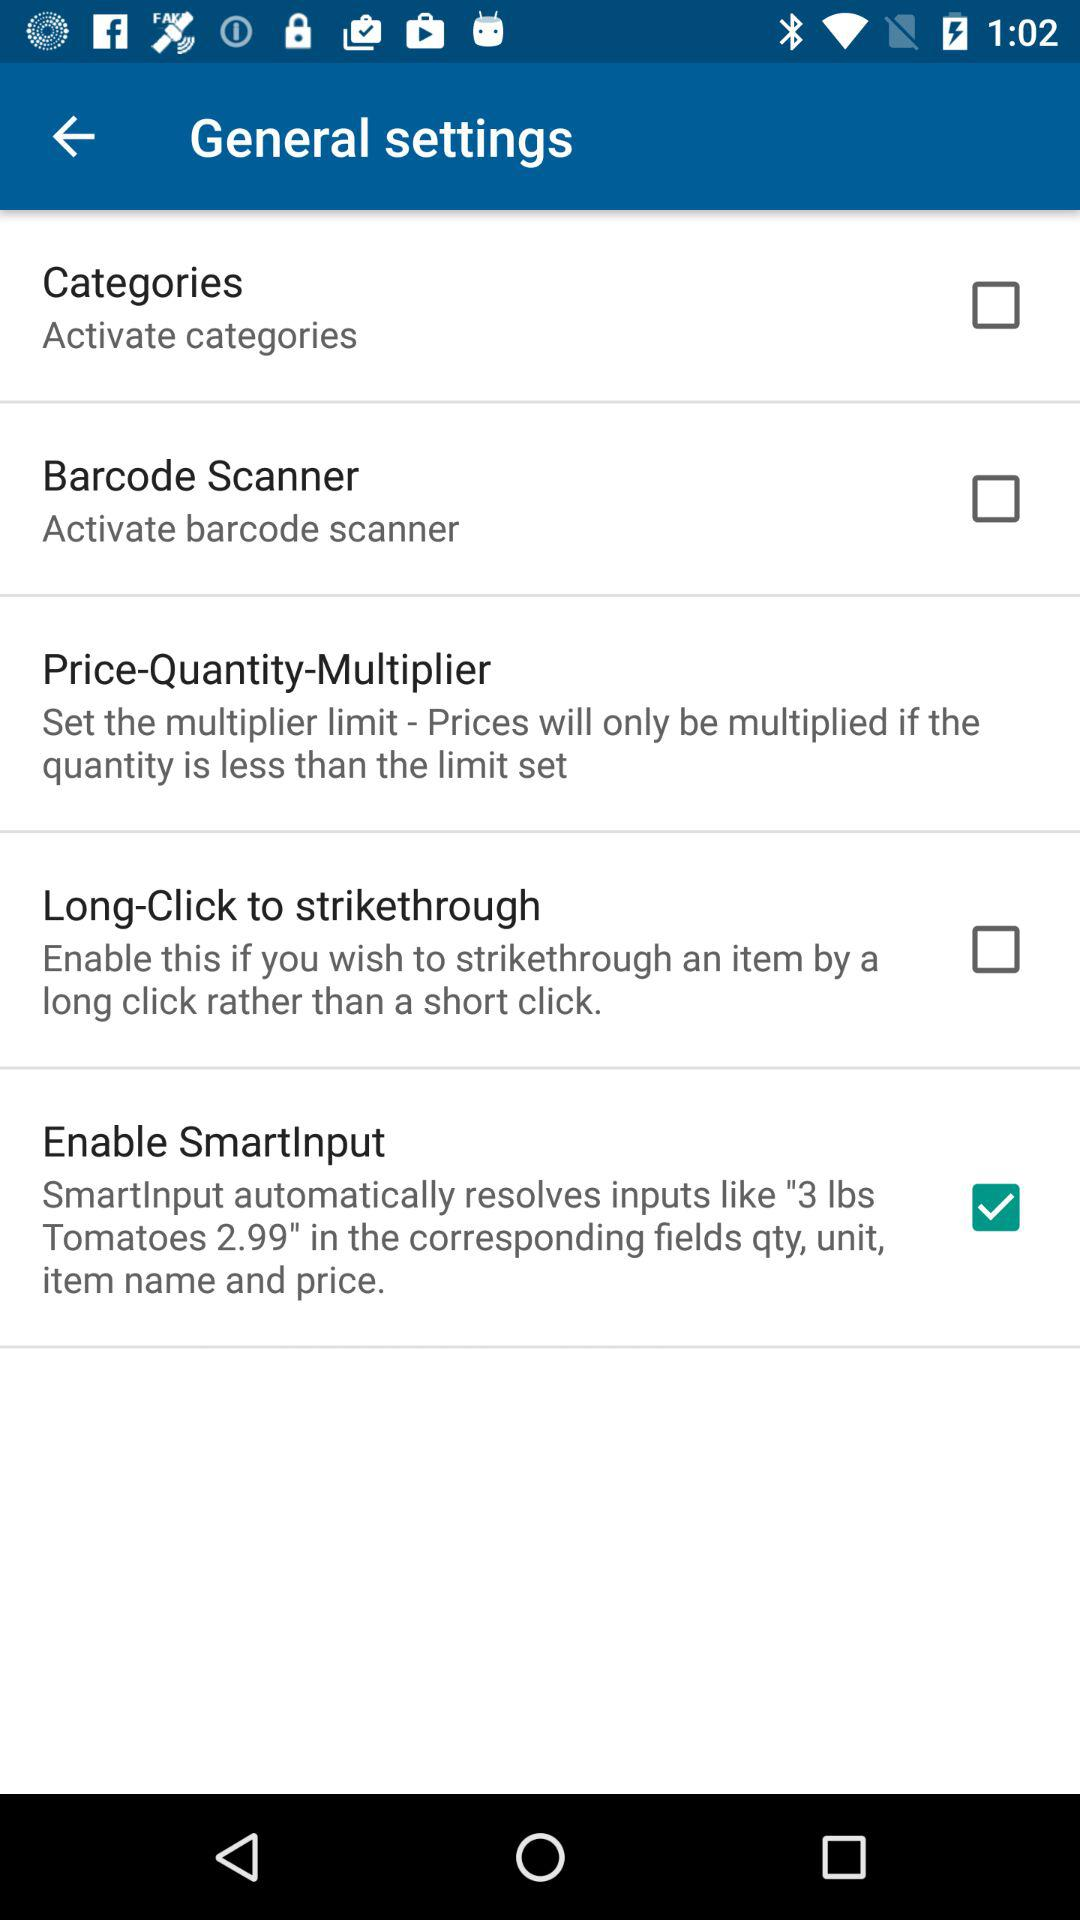What's the checked option in "General settings"? The checked option in "General settings" is "Enable SmartInput". 